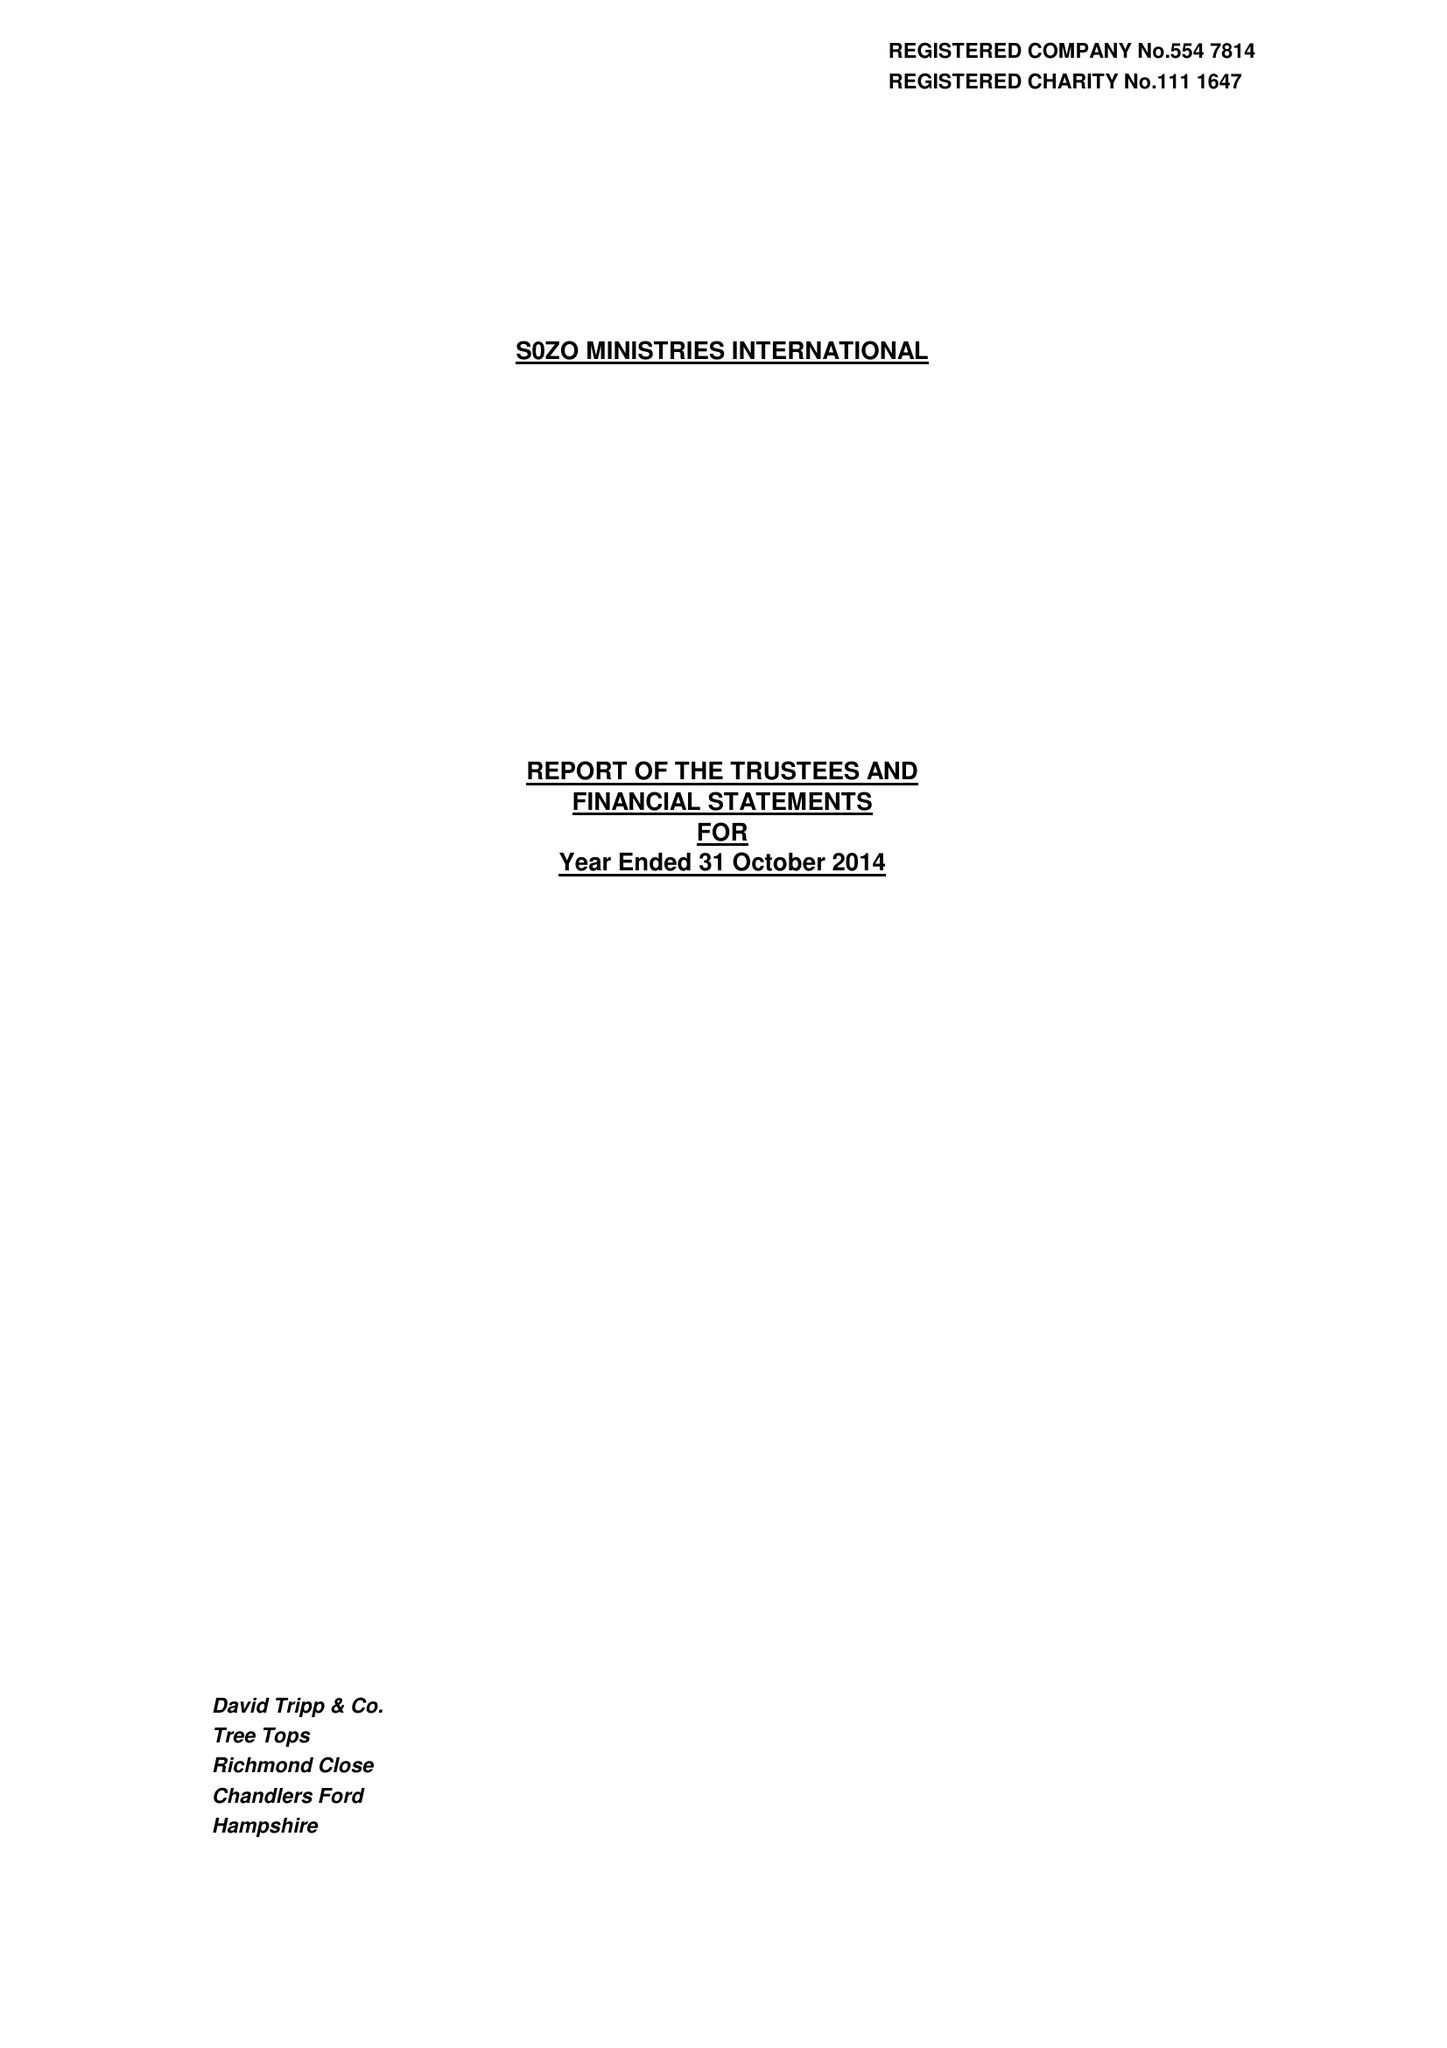What is the value for the income_annually_in_british_pounds?
Answer the question using a single word or phrase. 843441.00 